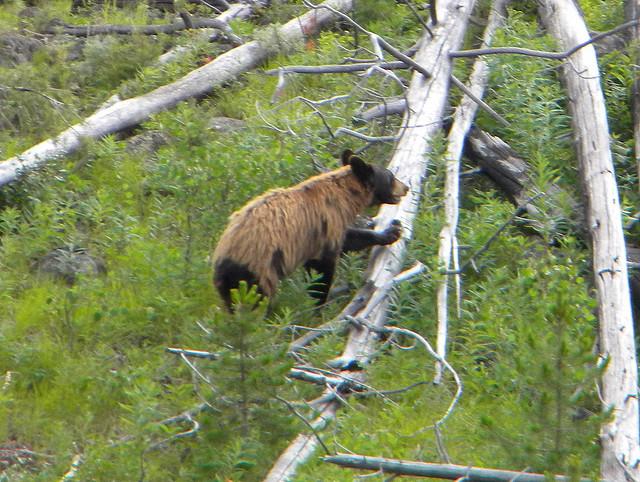Where is the bear?
Keep it brief. Forrest. Are there many animals with the bear?
Keep it brief. No. Has the tree fallen?
Give a very brief answer. Yes. 